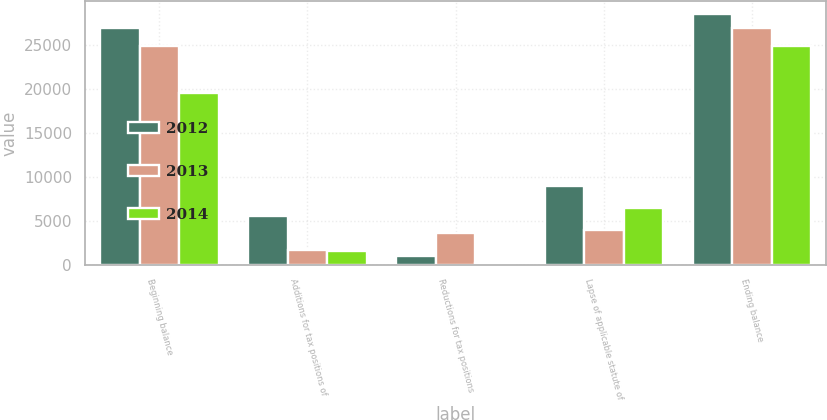Convert chart. <chart><loc_0><loc_0><loc_500><loc_500><stacked_bar_chart><ecel><fcel>Beginning balance<fcel>Additions for tax positions of<fcel>Reductions for tax positions<fcel>Lapse of applicable statute of<fcel>Ending balance<nl><fcel>2012<fcel>26924<fcel>5571<fcel>1008<fcel>8934<fcel>28567<nl><fcel>2013<fcel>24865<fcel>1639<fcel>3675<fcel>3986<fcel>26924<nl><fcel>2014<fcel>19556<fcel>1541<fcel>197<fcel>6522<fcel>24865<nl></chart> 